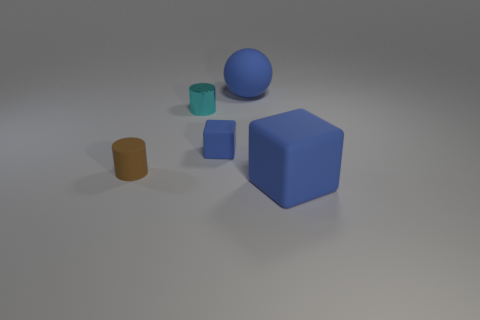The rubber cube that is to the right of the blue block that is left of the big rubber object right of the big blue matte sphere is what color?
Your response must be concise. Blue. What number of objects are either small shiny things or small green matte objects?
Provide a succinct answer. 1. What number of brown matte objects have the same shape as the shiny thing?
Give a very brief answer. 1. Does the large ball have the same material as the tiny brown cylinder that is behind the large matte cube?
Your answer should be very brief. Yes. What size is the blue ball that is the same material as the small brown thing?
Offer a terse response. Large. What is the size of the matte block to the left of the sphere?
Offer a terse response. Small. What number of blue rubber cubes have the same size as the brown rubber cylinder?
Provide a short and direct response. 1. What is the size of the other rubber cube that is the same color as the small matte block?
Your response must be concise. Large. Are there any tiny metallic cylinders that have the same color as the large matte cube?
Your response must be concise. No. There is a matte block that is the same size as the sphere; what is its color?
Provide a succinct answer. Blue. 